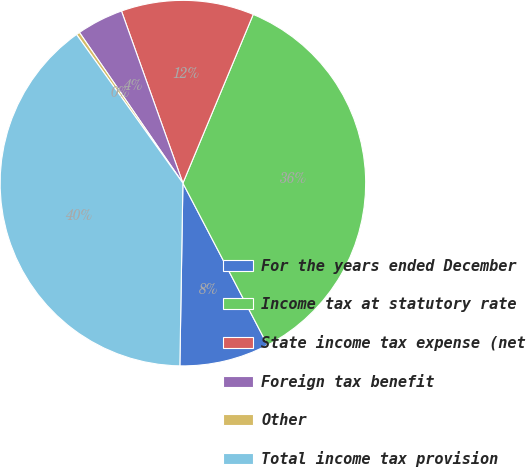Convert chart to OTSL. <chart><loc_0><loc_0><loc_500><loc_500><pie_chart><fcel>For the years ended December<fcel>Income tax at statutory rate<fcel>State income tax expense (net<fcel>Foreign tax benefit<fcel>Other<fcel>Total income tax provision<nl><fcel>7.93%<fcel>36.05%<fcel>11.74%<fcel>4.12%<fcel>0.31%<fcel>39.85%<nl></chart> 